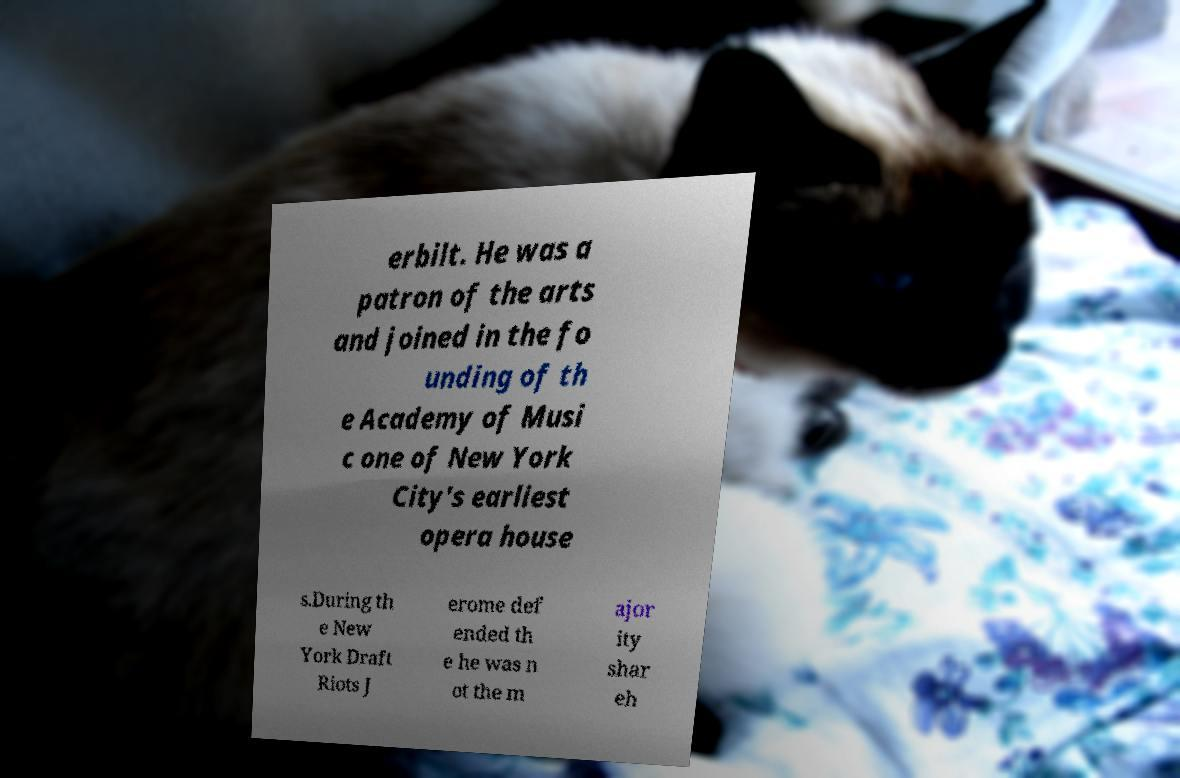Could you assist in decoding the text presented in this image and type it out clearly? erbilt. He was a patron of the arts and joined in the fo unding of th e Academy of Musi c one of New York City's earliest opera house s.During th e New York Draft Riots J erome def ended th e he was n ot the m ajor ity shar eh 